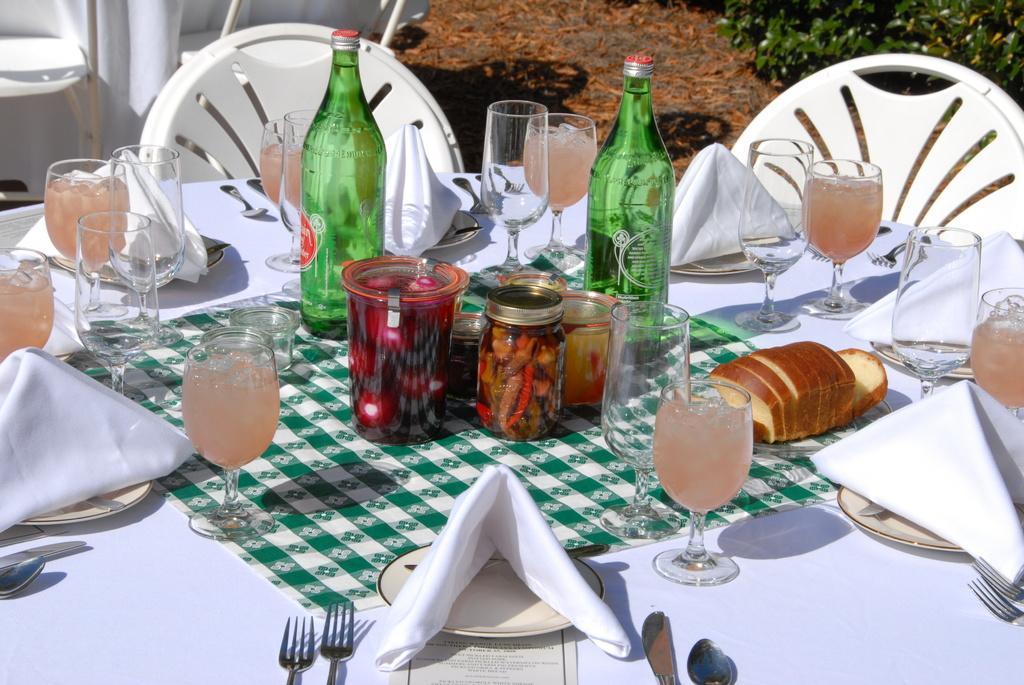Could you give a brief overview of what you see in this image? I can see in this image table with white color, on the table we have few glass bottles, glasses and other objects on it. Beside the table we have two chairs. 